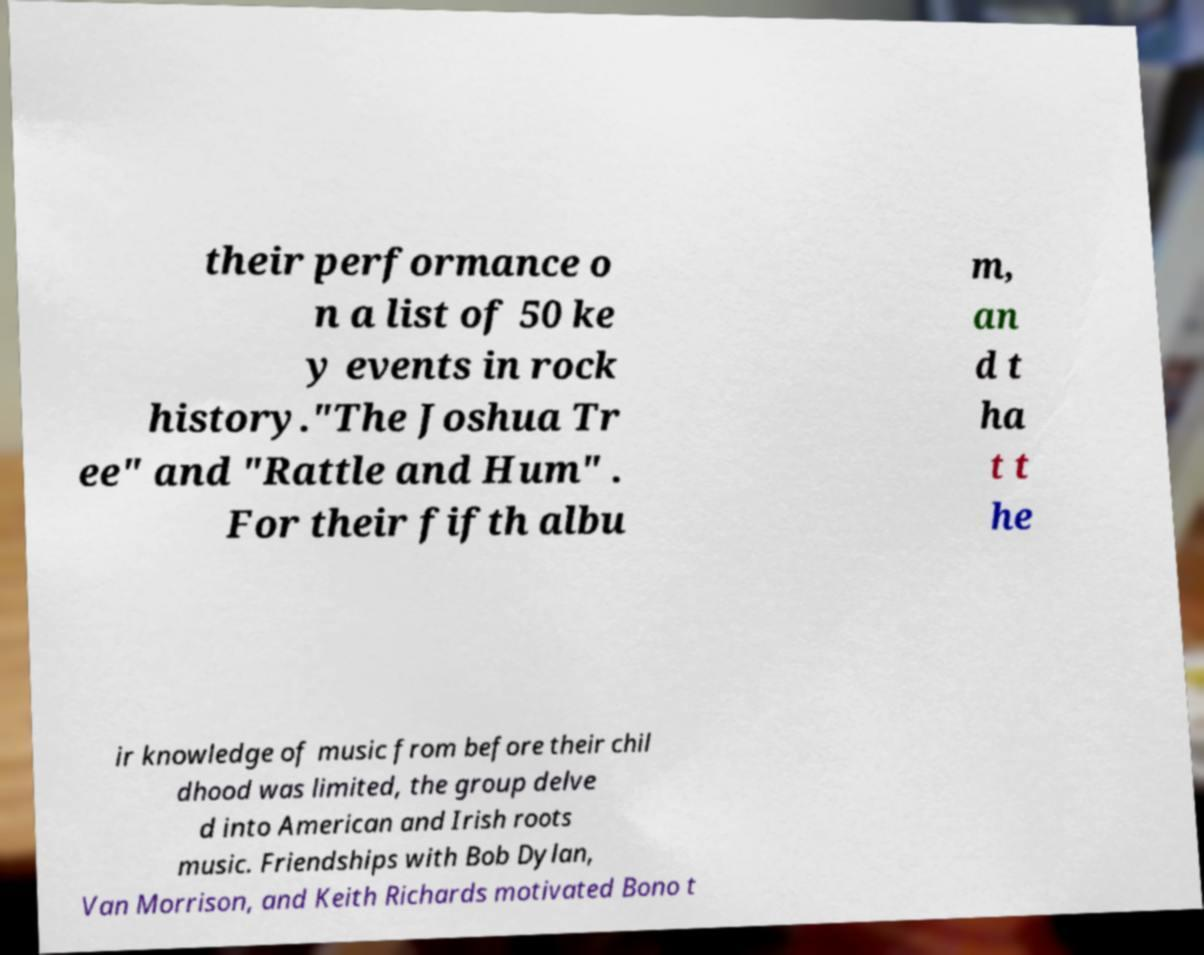Could you assist in decoding the text presented in this image and type it out clearly? their performance o n a list of 50 ke y events in rock history."The Joshua Tr ee" and "Rattle and Hum" . For their fifth albu m, an d t ha t t he ir knowledge of music from before their chil dhood was limited, the group delve d into American and Irish roots music. Friendships with Bob Dylan, Van Morrison, and Keith Richards motivated Bono t 